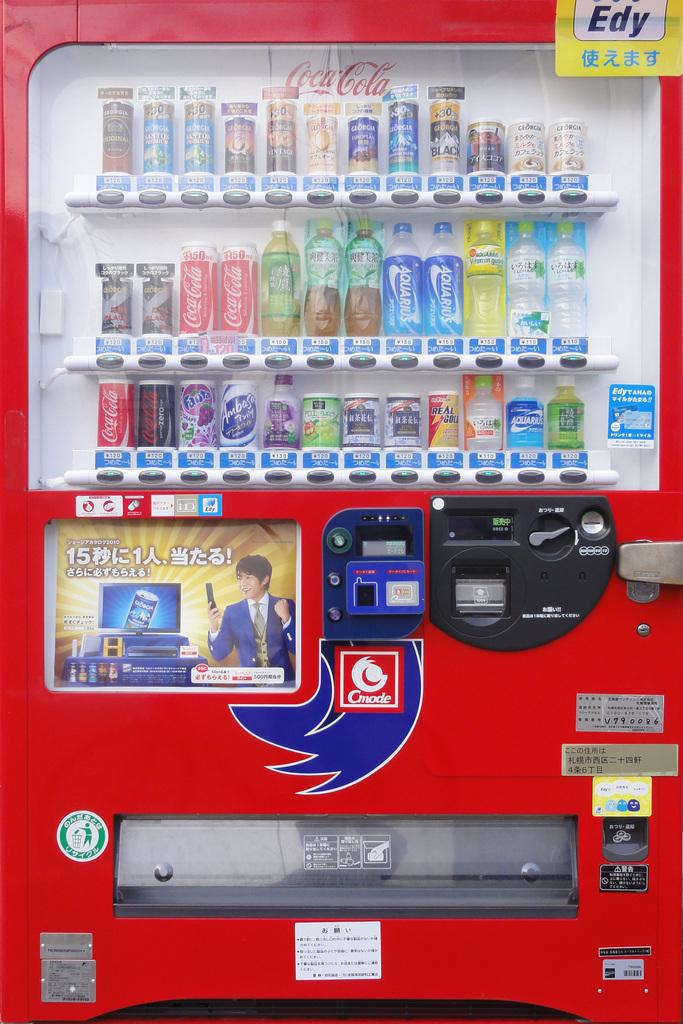<image>
Relay a brief, clear account of the picture shown. An Asian vending machine with beverages in it. 